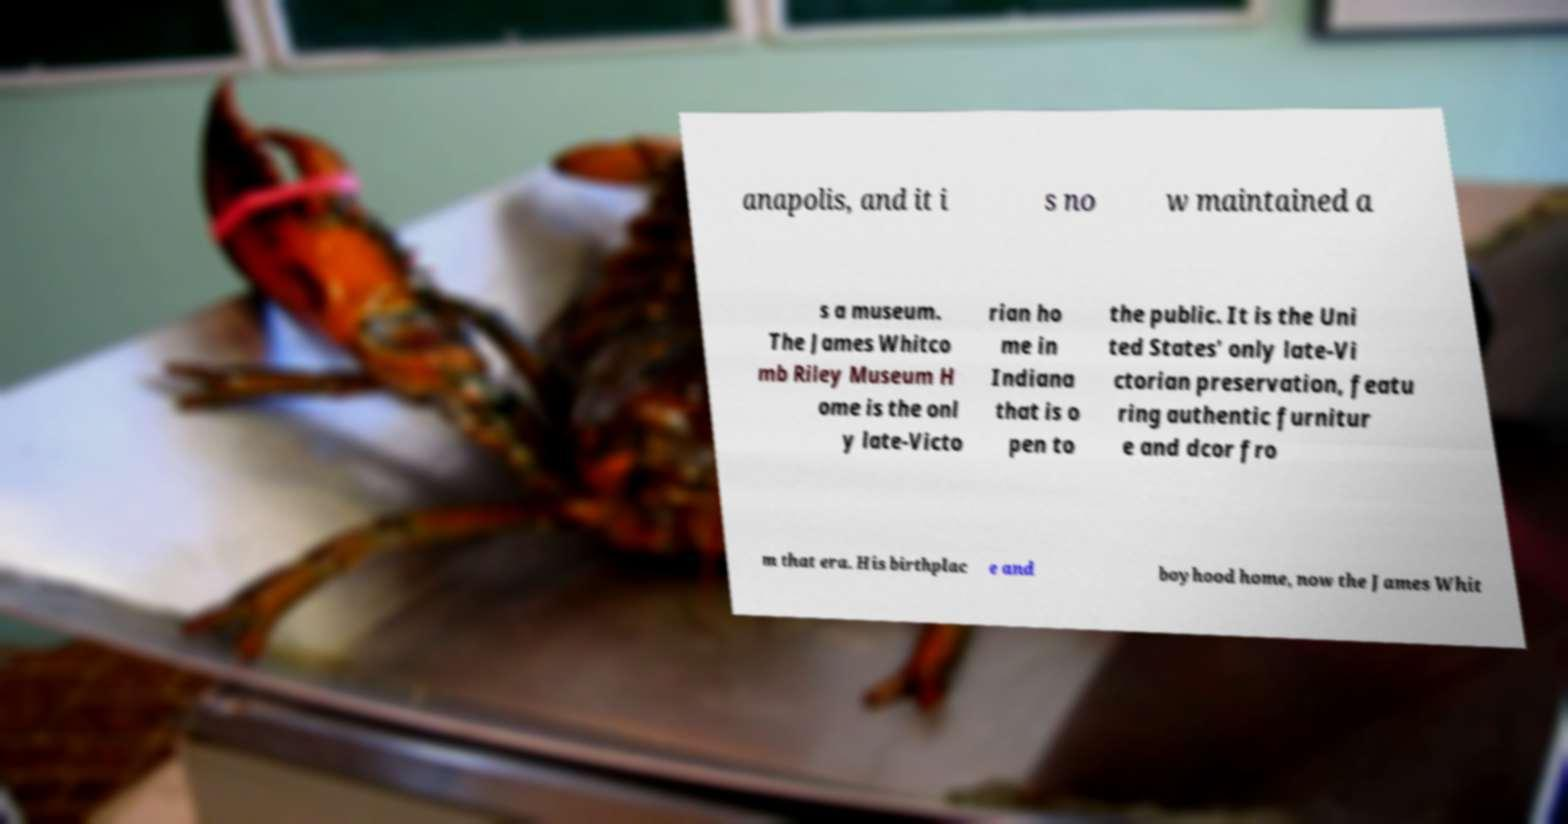Please identify and transcribe the text found in this image. anapolis, and it i s no w maintained a s a museum. The James Whitco mb Riley Museum H ome is the onl y late-Victo rian ho me in Indiana that is o pen to the public. It is the Uni ted States' only late-Vi ctorian preservation, featu ring authentic furnitur e and dcor fro m that era. His birthplac e and boyhood home, now the James Whit 